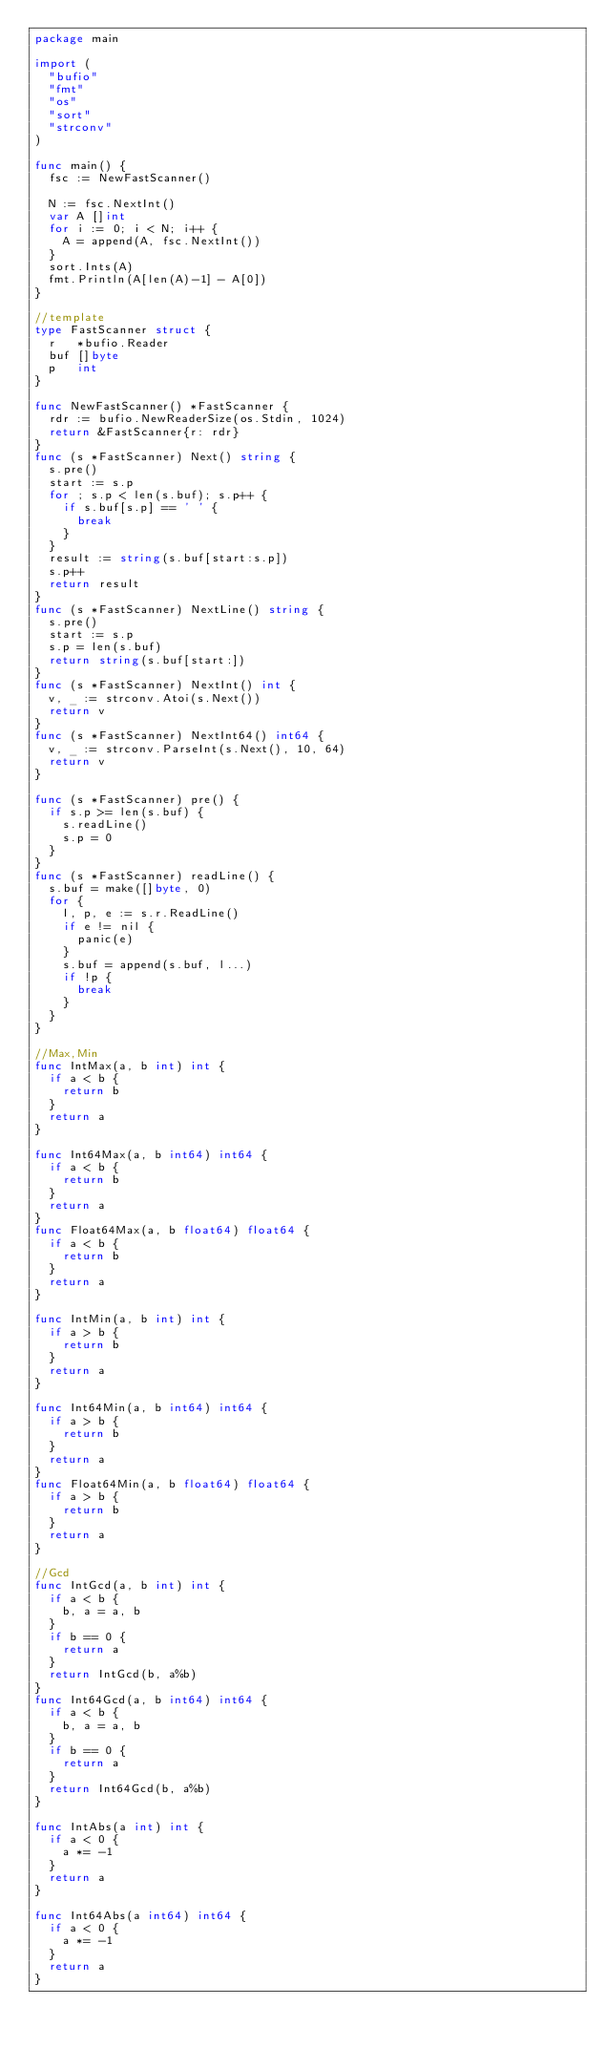Convert code to text. <code><loc_0><loc_0><loc_500><loc_500><_Go_>package main

import (
	"bufio"
	"fmt"
	"os"
	"sort"
	"strconv"
)

func main() {
	fsc := NewFastScanner()

	N := fsc.NextInt()
	var A []int
	for i := 0; i < N; i++ {
		A = append(A, fsc.NextInt())
	}
	sort.Ints(A)
	fmt.Println(A[len(A)-1] - A[0])
}

//template
type FastScanner struct {
	r   *bufio.Reader
	buf []byte
	p   int
}

func NewFastScanner() *FastScanner {
	rdr := bufio.NewReaderSize(os.Stdin, 1024)
	return &FastScanner{r: rdr}
}
func (s *FastScanner) Next() string {
	s.pre()
	start := s.p
	for ; s.p < len(s.buf); s.p++ {
		if s.buf[s.p] == ' ' {
			break
		}
	}
	result := string(s.buf[start:s.p])
	s.p++
	return result
}
func (s *FastScanner) NextLine() string {
	s.pre()
	start := s.p
	s.p = len(s.buf)
	return string(s.buf[start:])
}
func (s *FastScanner) NextInt() int {
	v, _ := strconv.Atoi(s.Next())
	return v
}
func (s *FastScanner) NextInt64() int64 {
	v, _ := strconv.ParseInt(s.Next(), 10, 64)
	return v
}

func (s *FastScanner) pre() {
	if s.p >= len(s.buf) {
		s.readLine()
		s.p = 0
	}
}
func (s *FastScanner) readLine() {
	s.buf = make([]byte, 0)
	for {
		l, p, e := s.r.ReadLine()
		if e != nil {
			panic(e)
		}
		s.buf = append(s.buf, l...)
		if !p {
			break
		}
	}
}

//Max,Min
func IntMax(a, b int) int {
	if a < b {
		return b
	}
	return a
}

func Int64Max(a, b int64) int64 {
	if a < b {
		return b
	}
	return a
}
func Float64Max(a, b float64) float64 {
	if a < b {
		return b
	}
	return a
}

func IntMin(a, b int) int {
	if a > b {
		return b
	}
	return a
}

func Int64Min(a, b int64) int64 {
	if a > b {
		return b
	}
	return a
}
func Float64Min(a, b float64) float64 {
	if a > b {
		return b
	}
	return a
}

//Gcd
func IntGcd(a, b int) int {
	if a < b {
		b, a = a, b
	}
	if b == 0 {
		return a
	}
	return IntGcd(b, a%b)
}
func Int64Gcd(a, b int64) int64 {
	if a < b {
		b, a = a, b
	}
	if b == 0 {
		return a
	}
	return Int64Gcd(b, a%b)
}

func IntAbs(a int) int {
	if a < 0 {
		a *= -1
	}
	return a
}

func Int64Abs(a int64) int64 {
	if a < 0 {
		a *= -1
	}
	return a
}
</code> 